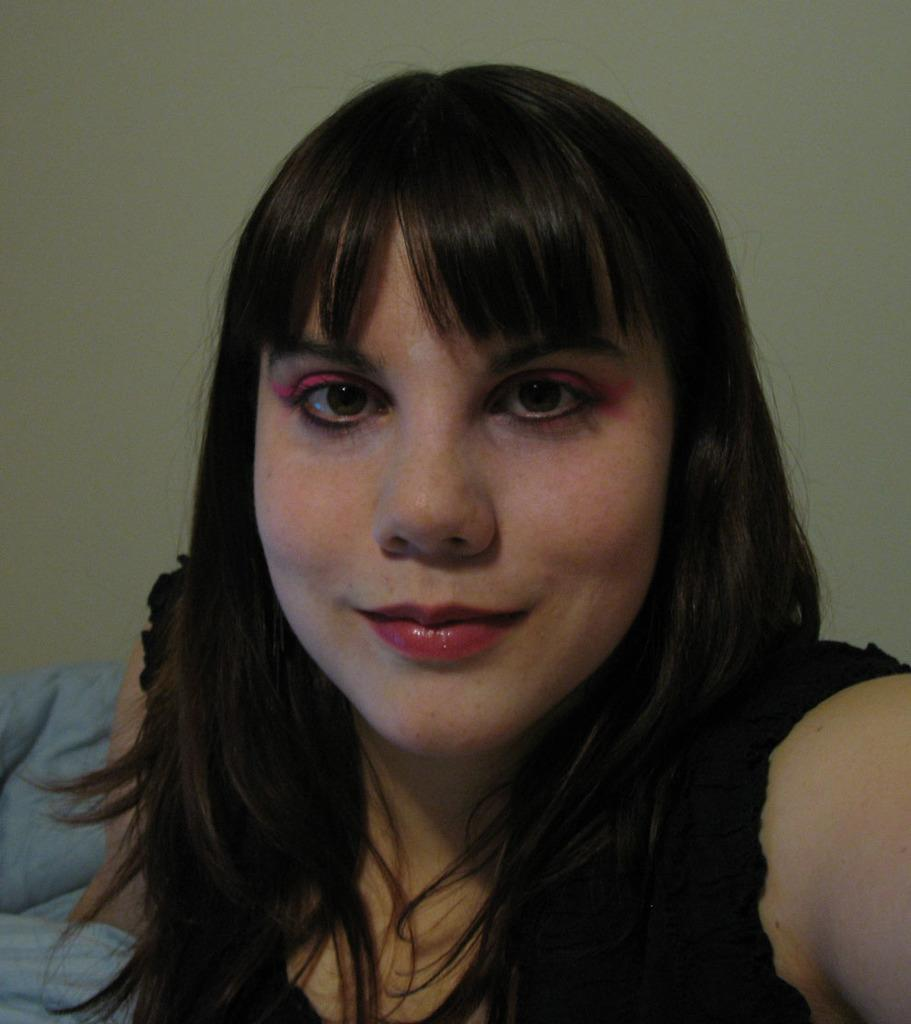Who is present in the image? There is a woman in the image. What is the woman's facial expression? The woman is smiling. What can be seen in the backdrop of the image? There is a blanket and a wall in the backdrop. What type of rhythm is the woman dancing to in the image? There is no indication in the image that the woman is dancing, and therefore no rhythm can be determined. 